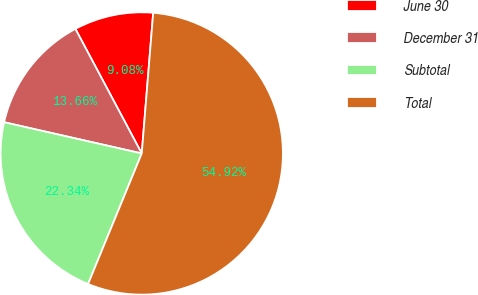Convert chart to OTSL. <chart><loc_0><loc_0><loc_500><loc_500><pie_chart><fcel>June 30<fcel>December 31<fcel>Subtotal<fcel>Total<nl><fcel>9.08%<fcel>13.66%<fcel>22.34%<fcel>54.91%<nl></chart> 